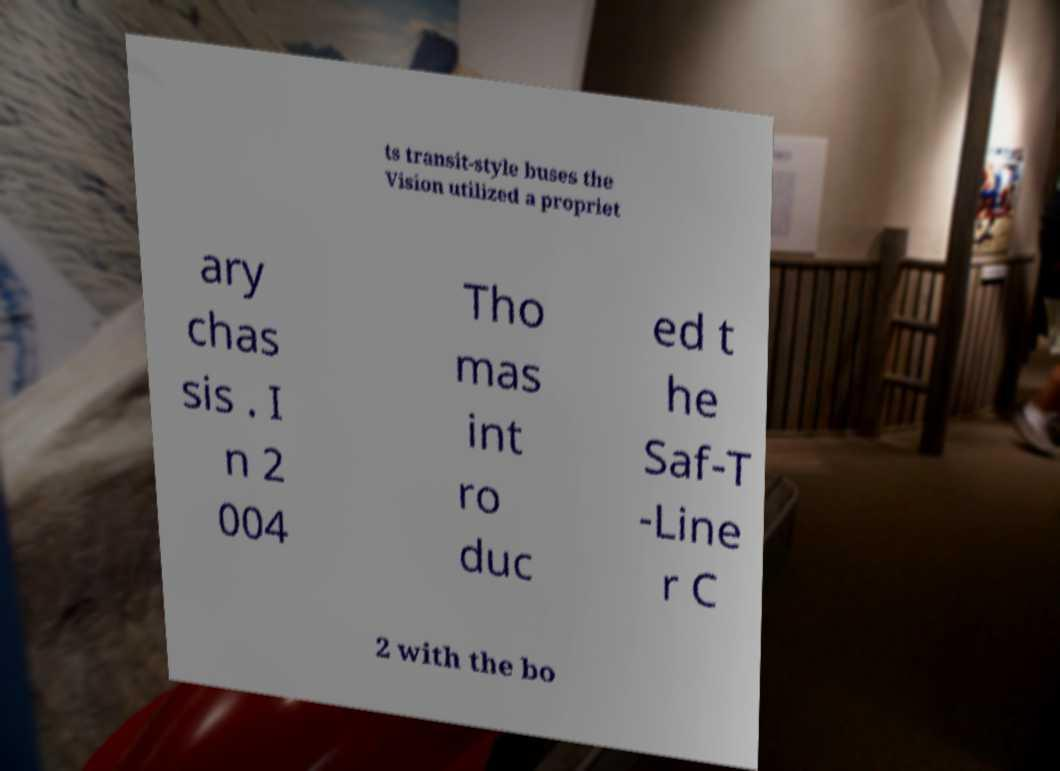For documentation purposes, I need the text within this image transcribed. Could you provide that? ts transit-style buses the Vision utilized a propriet ary chas sis . I n 2 004 Tho mas int ro duc ed t he Saf-T -Line r C 2 with the bo 